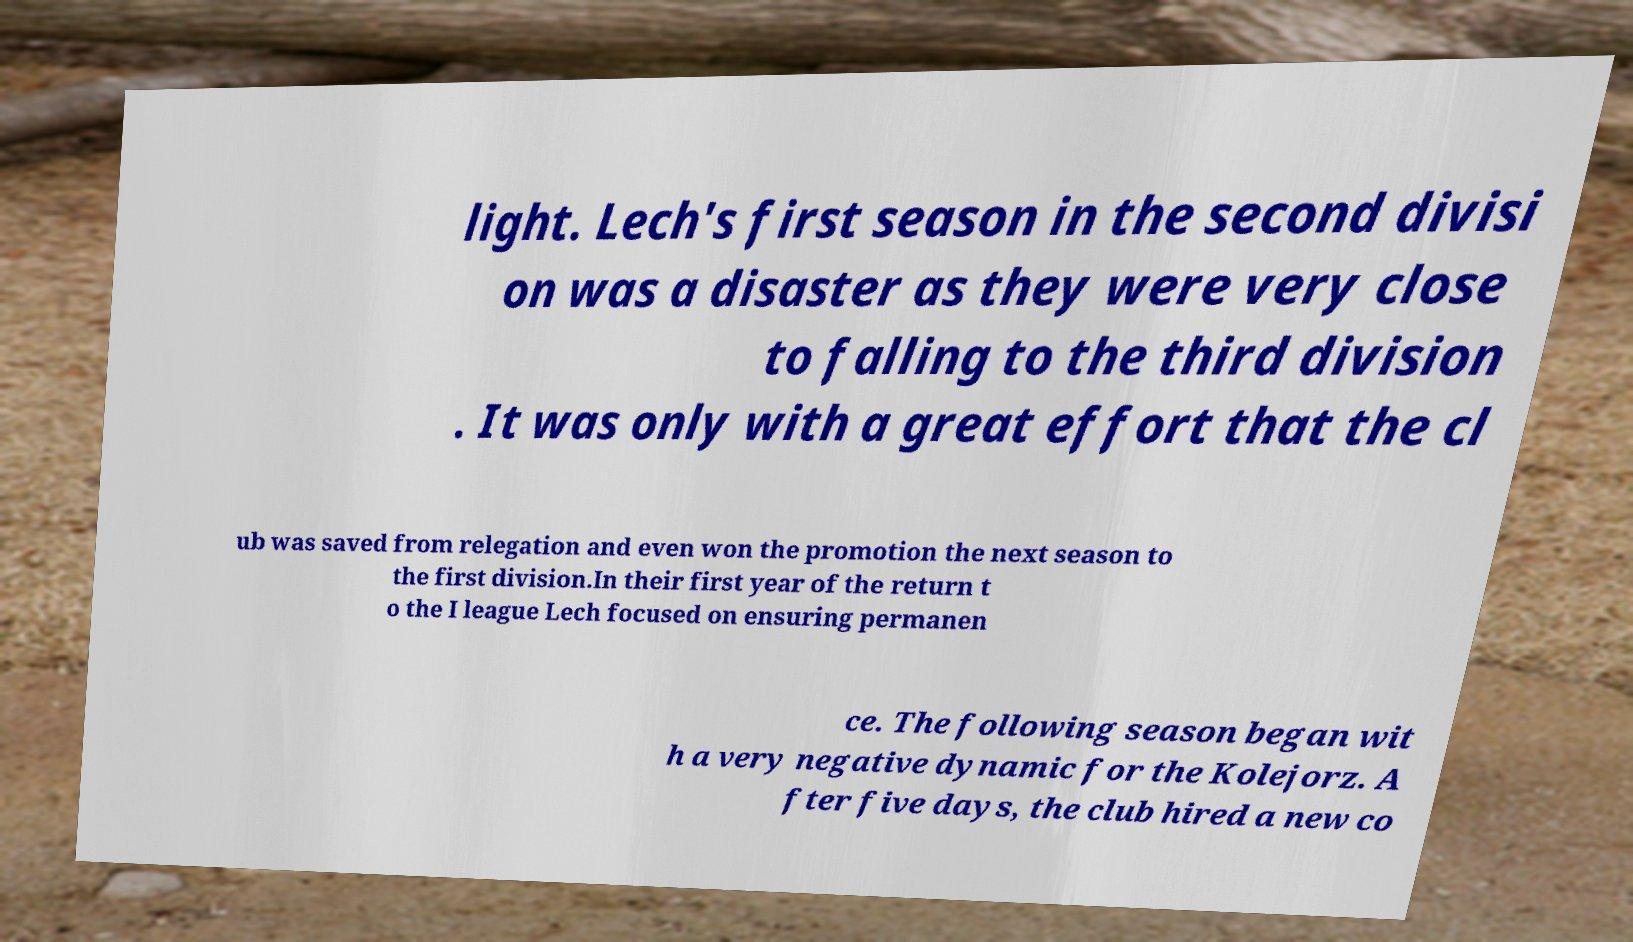Please identify and transcribe the text found in this image. light. Lech's first season in the second divisi on was a disaster as they were very close to falling to the third division . It was only with a great effort that the cl ub was saved from relegation and even won the promotion the next season to the first division.In their first year of the return t o the I league Lech focused on ensuring permanen ce. The following season began wit h a very negative dynamic for the Kolejorz. A fter five days, the club hired a new co 